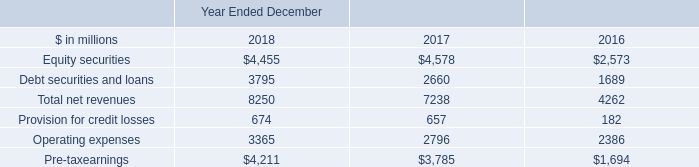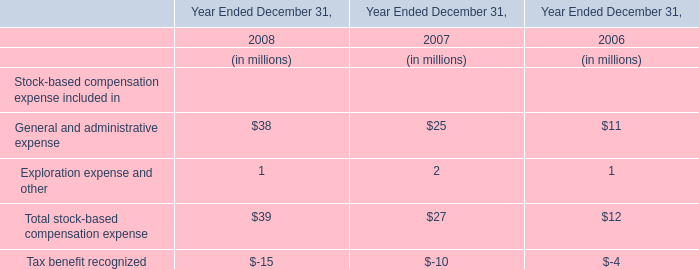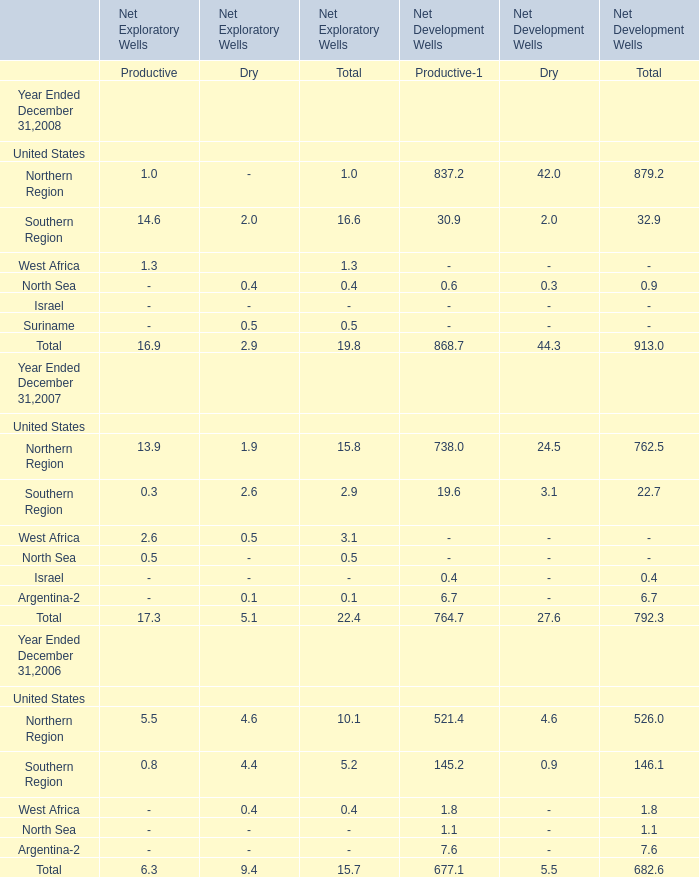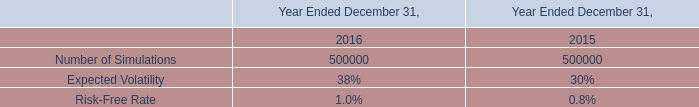what were net revenues in investing & lending in billions for 2017? 
Computations: (((100 - 14) / 100) * 8.25)
Answer: 7.095. 